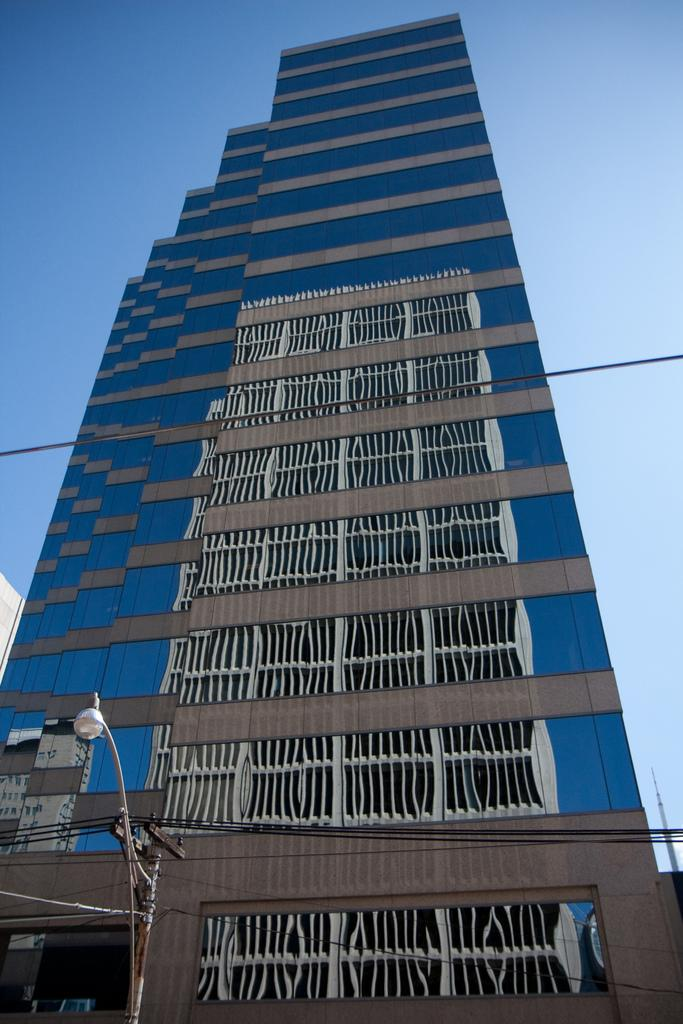What type of structure is visible in the image? There is a building in the image. What is located near the building? There is a fence in the image. What else can be seen in the image related to infrastructure? Electric wires and a light pole are visible in the image. What is the color of the sky in the image? The sky is pale blue in the image. What type of glass is being distributed by the building in the image? There is no glass being distributed in the image, nor is there any indication of a selection process. 